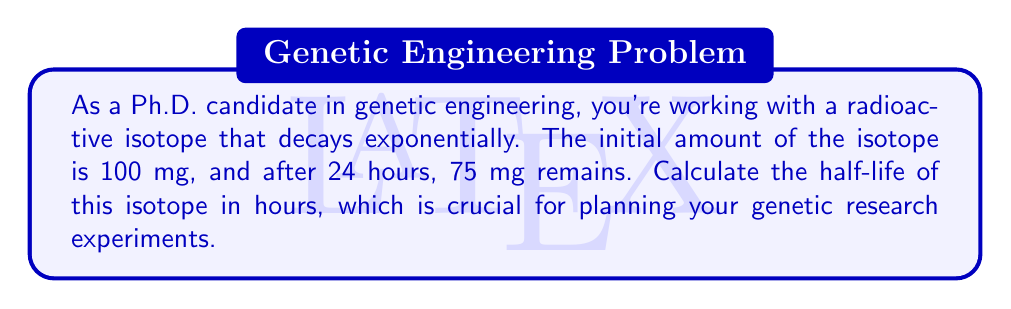Can you solve this math problem? Let's approach this step-by-step using the exponential decay formula and logarithms:

1) The exponential decay formula is:
   $A(t) = A_0 \cdot e^{-\lambda t}$
   where $A(t)$ is the amount at time $t$, $A_0$ is the initial amount, and $\lambda$ is the decay constant.

2) We know:
   $A_0 = 100$ mg
   $A(24) = 75$ mg
   $t = 24$ hours

3) Substituting into the formula:
   $75 = 100 \cdot e^{-24\lambda}$

4) Dividing both sides by 100:
   $0.75 = e^{-24\lambda}$

5) Taking the natural log of both sides:
   $\ln(0.75) = -24\lambda$

6) Solving for $\lambda$:
   $\lambda = -\frac{\ln(0.75)}{24} \approx 0.0120$ per hour

7) The half-life $t_{1/2}$ is related to $\lambda$ by:
   $t_{1/2} = \frac{\ln(2)}{\lambda}$

8) Substituting our value for $\lambda$:
   $t_{1/2} = \frac{\ln(2)}{0.0120} \approx 57.8$ hours

Thus, the half-life of the isotope is approximately 57.8 hours.
Answer: 57.8 hours 